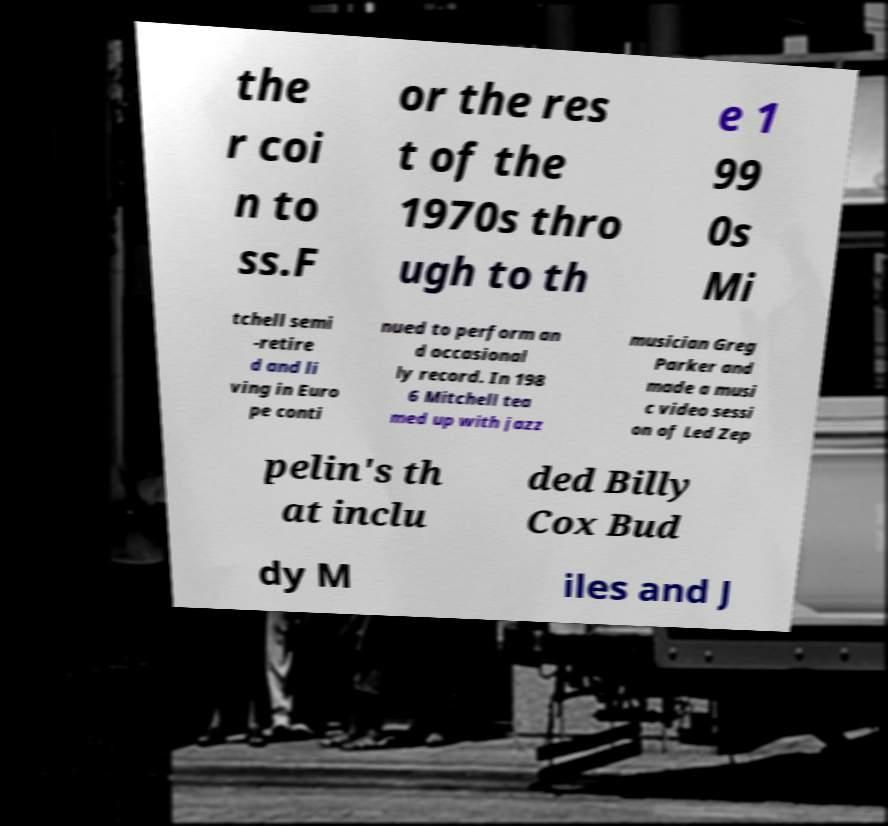Can you read and provide the text displayed in the image?This photo seems to have some interesting text. Can you extract and type it out for me? the r coi n to ss.F or the res t of the 1970s thro ugh to th e 1 99 0s Mi tchell semi -retire d and li ving in Euro pe conti nued to perform an d occasional ly record. In 198 6 Mitchell tea med up with jazz musician Greg Parker and made a musi c video sessi on of Led Zep pelin's th at inclu ded Billy Cox Bud dy M iles and J 